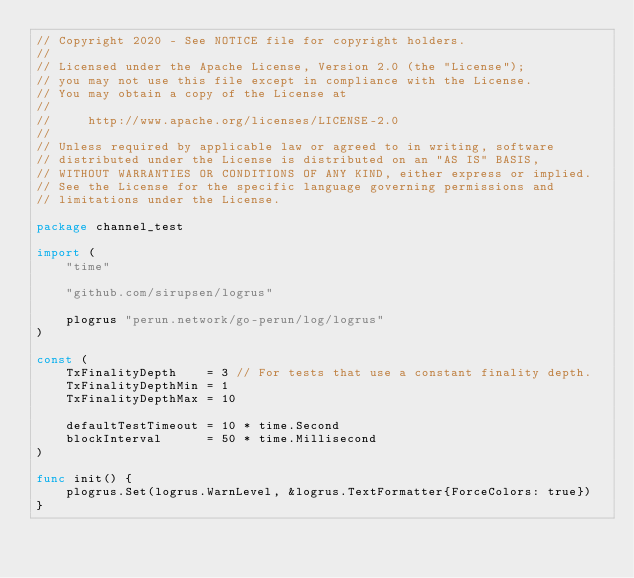<code> <loc_0><loc_0><loc_500><loc_500><_Go_>// Copyright 2020 - See NOTICE file for copyright holders.
//
// Licensed under the Apache License, Version 2.0 (the "License");
// you may not use this file except in compliance with the License.
// You may obtain a copy of the License at
//
//     http://www.apache.org/licenses/LICENSE-2.0
//
// Unless required by applicable law or agreed to in writing, software
// distributed under the License is distributed on an "AS IS" BASIS,
// WITHOUT WARRANTIES OR CONDITIONS OF ANY KIND, either express or implied.
// See the License for the specific language governing permissions and
// limitations under the License.

package channel_test

import (
	"time"

	"github.com/sirupsen/logrus"

	plogrus "perun.network/go-perun/log/logrus"
)

const (
	TxFinalityDepth    = 3 // For tests that use a constant finality depth.
	TxFinalityDepthMin = 1
	TxFinalityDepthMax = 10

	defaultTestTimeout = 10 * time.Second
	blockInterval      = 50 * time.Millisecond
)

func init() {
	plogrus.Set(logrus.WarnLevel, &logrus.TextFormatter{ForceColors: true})
}
</code> 